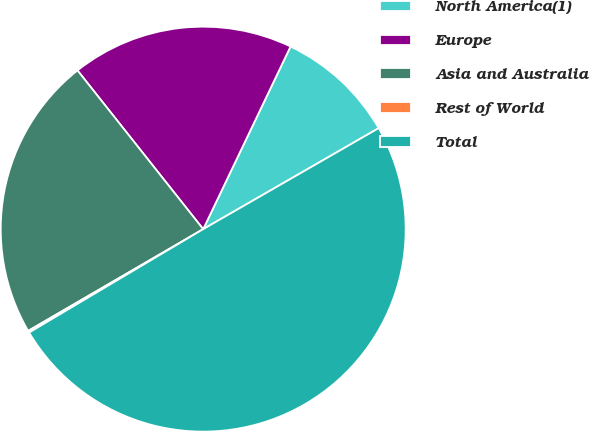Convert chart. <chart><loc_0><loc_0><loc_500><loc_500><pie_chart><fcel>North America(1)<fcel>Europe<fcel>Asia and Australia<fcel>Rest of World<fcel>Total<nl><fcel>9.59%<fcel>17.76%<fcel>22.72%<fcel>0.15%<fcel>49.78%<nl></chart> 